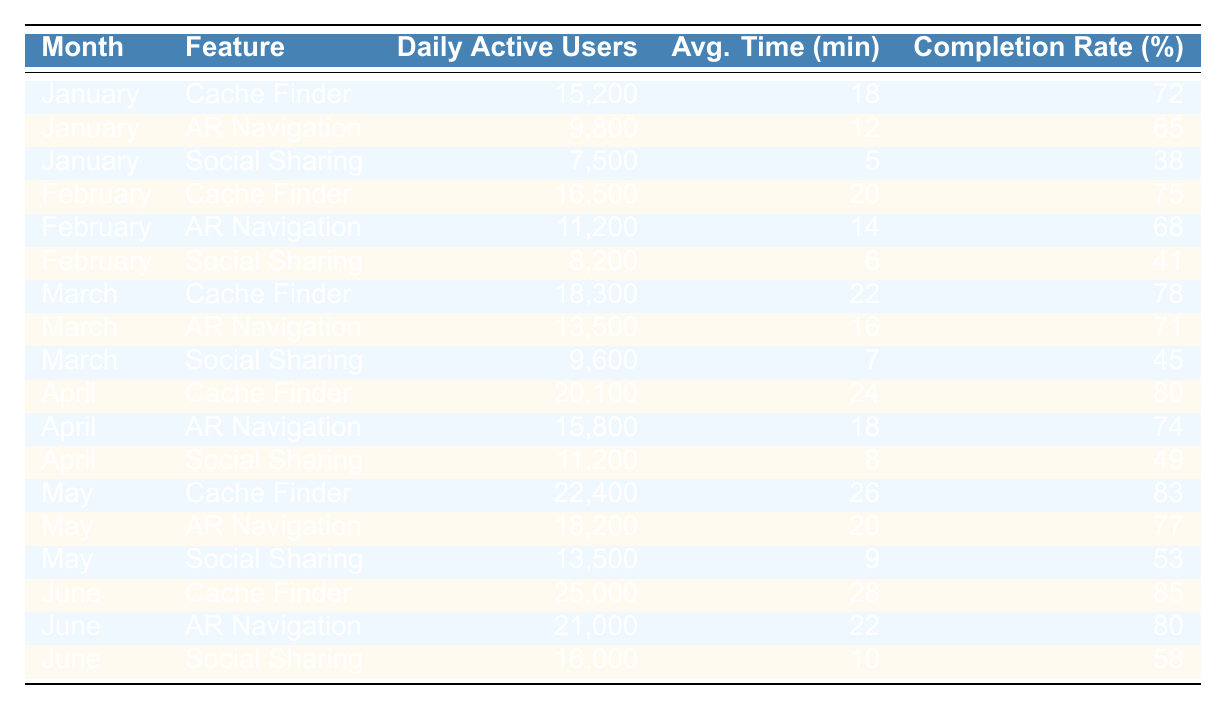What was the highest number of Daily Active Users for the Cache Finder feature? The highest number of Daily Active Users for the Cache Finder feature is found in June, which is 25,000.
Answer: 25,000 In which month did the AR Navigation feature have its lowest Average Time Spent? The AR Navigation feature had the lowest Average Time Spent in January with 12 minutes.
Answer: January What was the overall average Completion Rate across all features for the month of April? The Completion Rates for April are 80%, 74%, and 49%. The overall average is calculated as (80 + 74 + 49) / 3 = 67.67%.
Answer: 67.67% Did the Social Sharing feature have a higher Daily Active User count in February or March? In February, the count was 8,200 and in March, it was 9,600. March had a higher count.
Answer: Yes What was the increase in Daily Active Users for the Cache Finder feature from February to June? The Daily Active Users for Cache Finder in February were 16,500, and in June they were 25,000. The increase is 25,000 - 16,500 = 8,500.
Answer: 8,500 What is the average Average Time Spent for the Social Sharing feature from January to June? The Average Times Spent for Social Sharing from January to June are 5, 6, 7, 8, 9, and 10 minutes. The average is (5 + 6 + 7 + 8 + 9 + 10) / 6 = 7.5 minutes.
Answer: 7.5 Which feature had the highest Completion Rate in May? In May, the Completion Rates were 83%, 77%, and 53%. The highest was for Cache Finder at 83%.
Answer: Cache Finder What was the ratio of Daily Active Users between AR Navigation in June and Social Sharing in May? Daily Active Users for AR Navigation in June is 21,000 and for Social Sharing in May is 13,500. The ratio is 21,000:13,500, which simplifies to 14:9.
Answer: 14:9 In which month did the AR Navigation feature see the largest increase in Daily Active Users compared to the previous month? The increase from March to April is 15,800 - 13,500 = 2,300. From April to May, it's 18,200 - 15,800 = 2,400. From May to June, it's 21,000 - 18,200 = 2,800. The largest increase was from May to June.
Answer: May to June What percentage increase in Average Time Spent did the Cache Finder feature see from January to June? Cache Finder's Average Time Spent increased from 18 minutes in January to 28 minutes in June. The percentage increase is ((28 - 18) / 18) * 100 = 55.56%.
Answer: 55.56% 